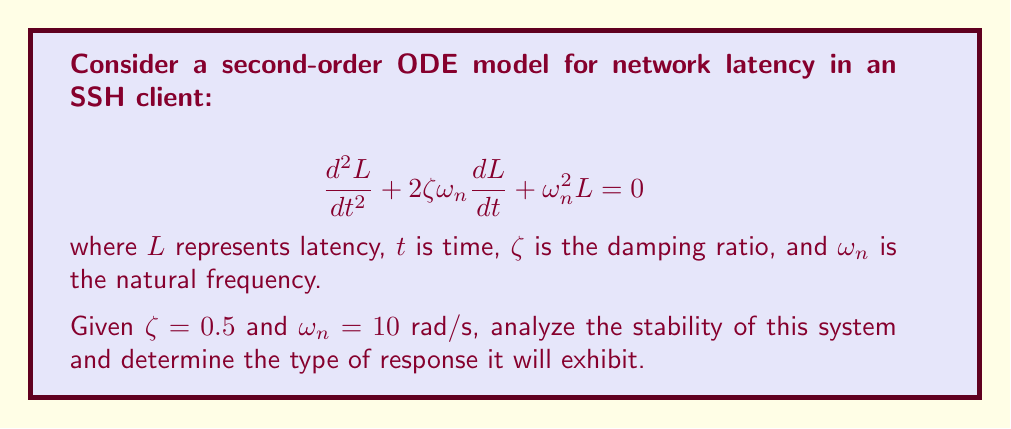Give your solution to this math problem. To analyze the stability of this second-order ODE, we follow these steps:

1) The characteristic equation for this ODE is:
   $$ s^2 + 2\zeta\omega_n s + \omega_n^2 = 0 $$

2) Substituting the given values:
   $$ s^2 + 2(0.5)(10)s + 10^2 = 0 $$
   $$ s^2 + 10s + 100 = 0 $$

3) Solve for the roots using the quadratic formula:
   $$ s = \frac{-b \pm \sqrt{b^2 - 4ac}}{2a} $$
   $$ s = \frac{-10 \pm \sqrt{10^2 - 4(1)(100)}}{2(1)} $$
   $$ s = \frac{-10 \pm \sqrt{0}}{2} = -5 $$

4) The roots are real and equal: $s_1 = s_2 = -5$

5) Since both roots are negative real numbers, the system is stable.

6) The damping ratio $\zeta = 0.5$ indicates that this is a critically damped system.

7) In the context of network latency for an SSH client, this means:
   - The latency will approach a steady-state value without oscillation.
   - The response will be the fastest possible without overshooting the target value.
   - This is ideal for minimizing connection setup time and maintaining stable performance.
Answer: The system is stable and critically damped. 